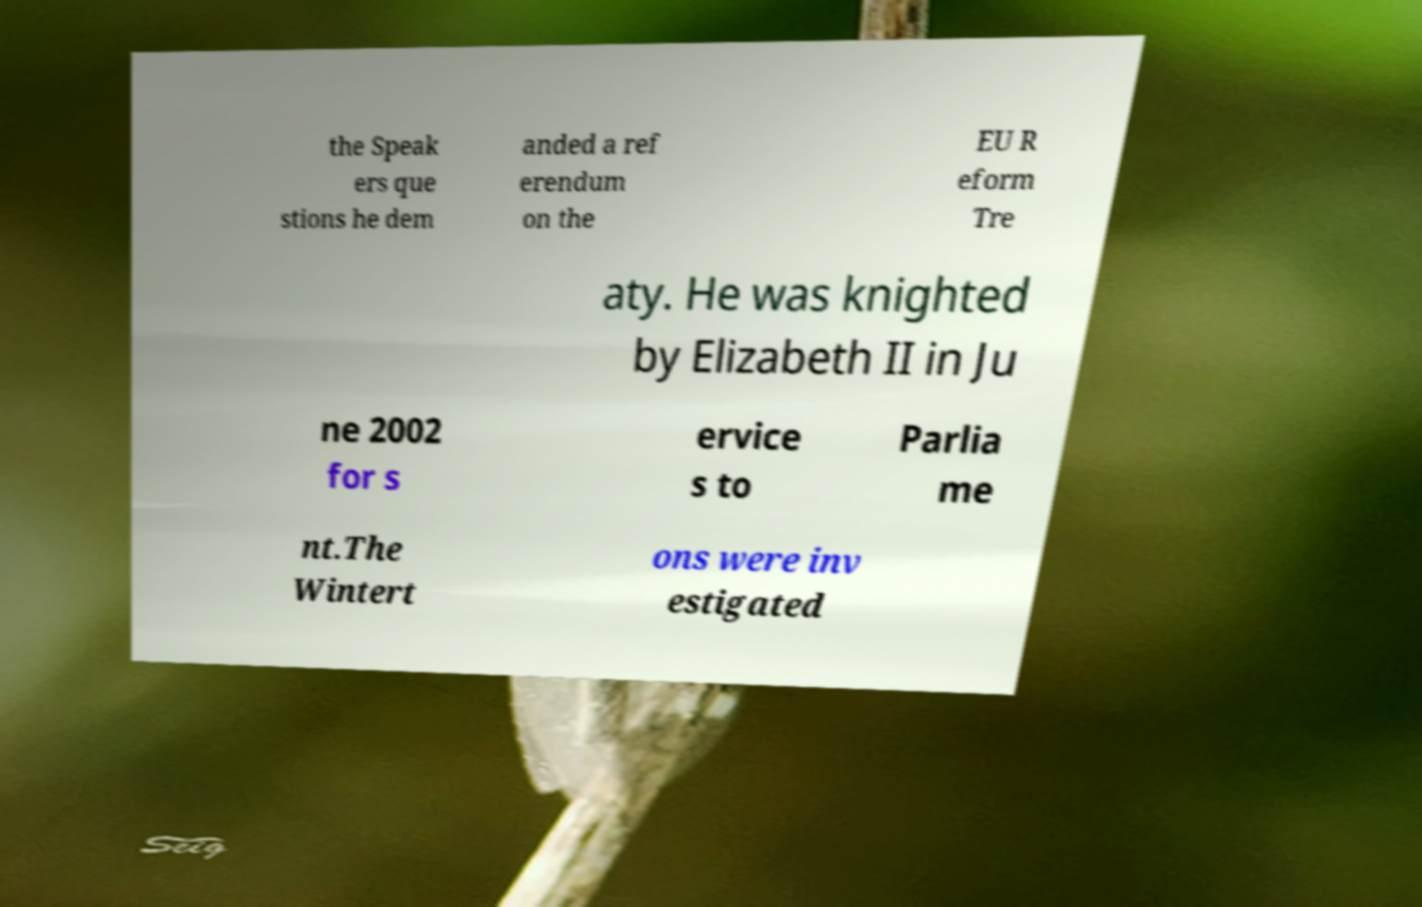Please identify and transcribe the text found in this image. the Speak ers que stions he dem anded a ref erendum on the EU R eform Tre aty. He was knighted by Elizabeth II in Ju ne 2002 for s ervice s to Parlia me nt.The Wintert ons were inv estigated 